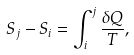<formula> <loc_0><loc_0><loc_500><loc_500>S _ { j } - S _ { i } = \int ^ { j } _ { i } \frac { \delta Q } { T } ,</formula> 